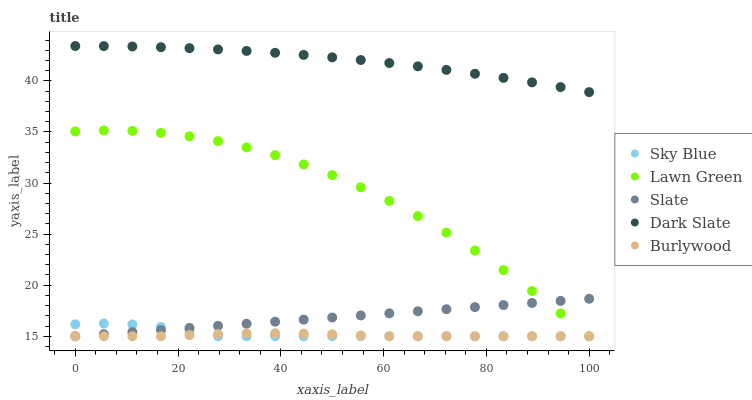Does Burlywood have the minimum area under the curve?
Answer yes or no. Yes. Does Dark Slate have the maximum area under the curve?
Answer yes or no. Yes. Does Sky Blue have the minimum area under the curve?
Answer yes or no. No. Does Sky Blue have the maximum area under the curve?
Answer yes or no. No. Is Slate the smoothest?
Answer yes or no. Yes. Is Lawn Green the roughest?
Answer yes or no. Yes. Is Sky Blue the smoothest?
Answer yes or no. No. Is Sky Blue the roughest?
Answer yes or no. No. Does Burlywood have the lowest value?
Answer yes or no. Yes. Does Dark Slate have the lowest value?
Answer yes or no. No. Does Dark Slate have the highest value?
Answer yes or no. Yes. Does Sky Blue have the highest value?
Answer yes or no. No. Is Sky Blue less than Dark Slate?
Answer yes or no. Yes. Is Dark Slate greater than Slate?
Answer yes or no. Yes. Does Sky Blue intersect Burlywood?
Answer yes or no. Yes. Is Sky Blue less than Burlywood?
Answer yes or no. No. Is Sky Blue greater than Burlywood?
Answer yes or no. No. Does Sky Blue intersect Dark Slate?
Answer yes or no. No. 